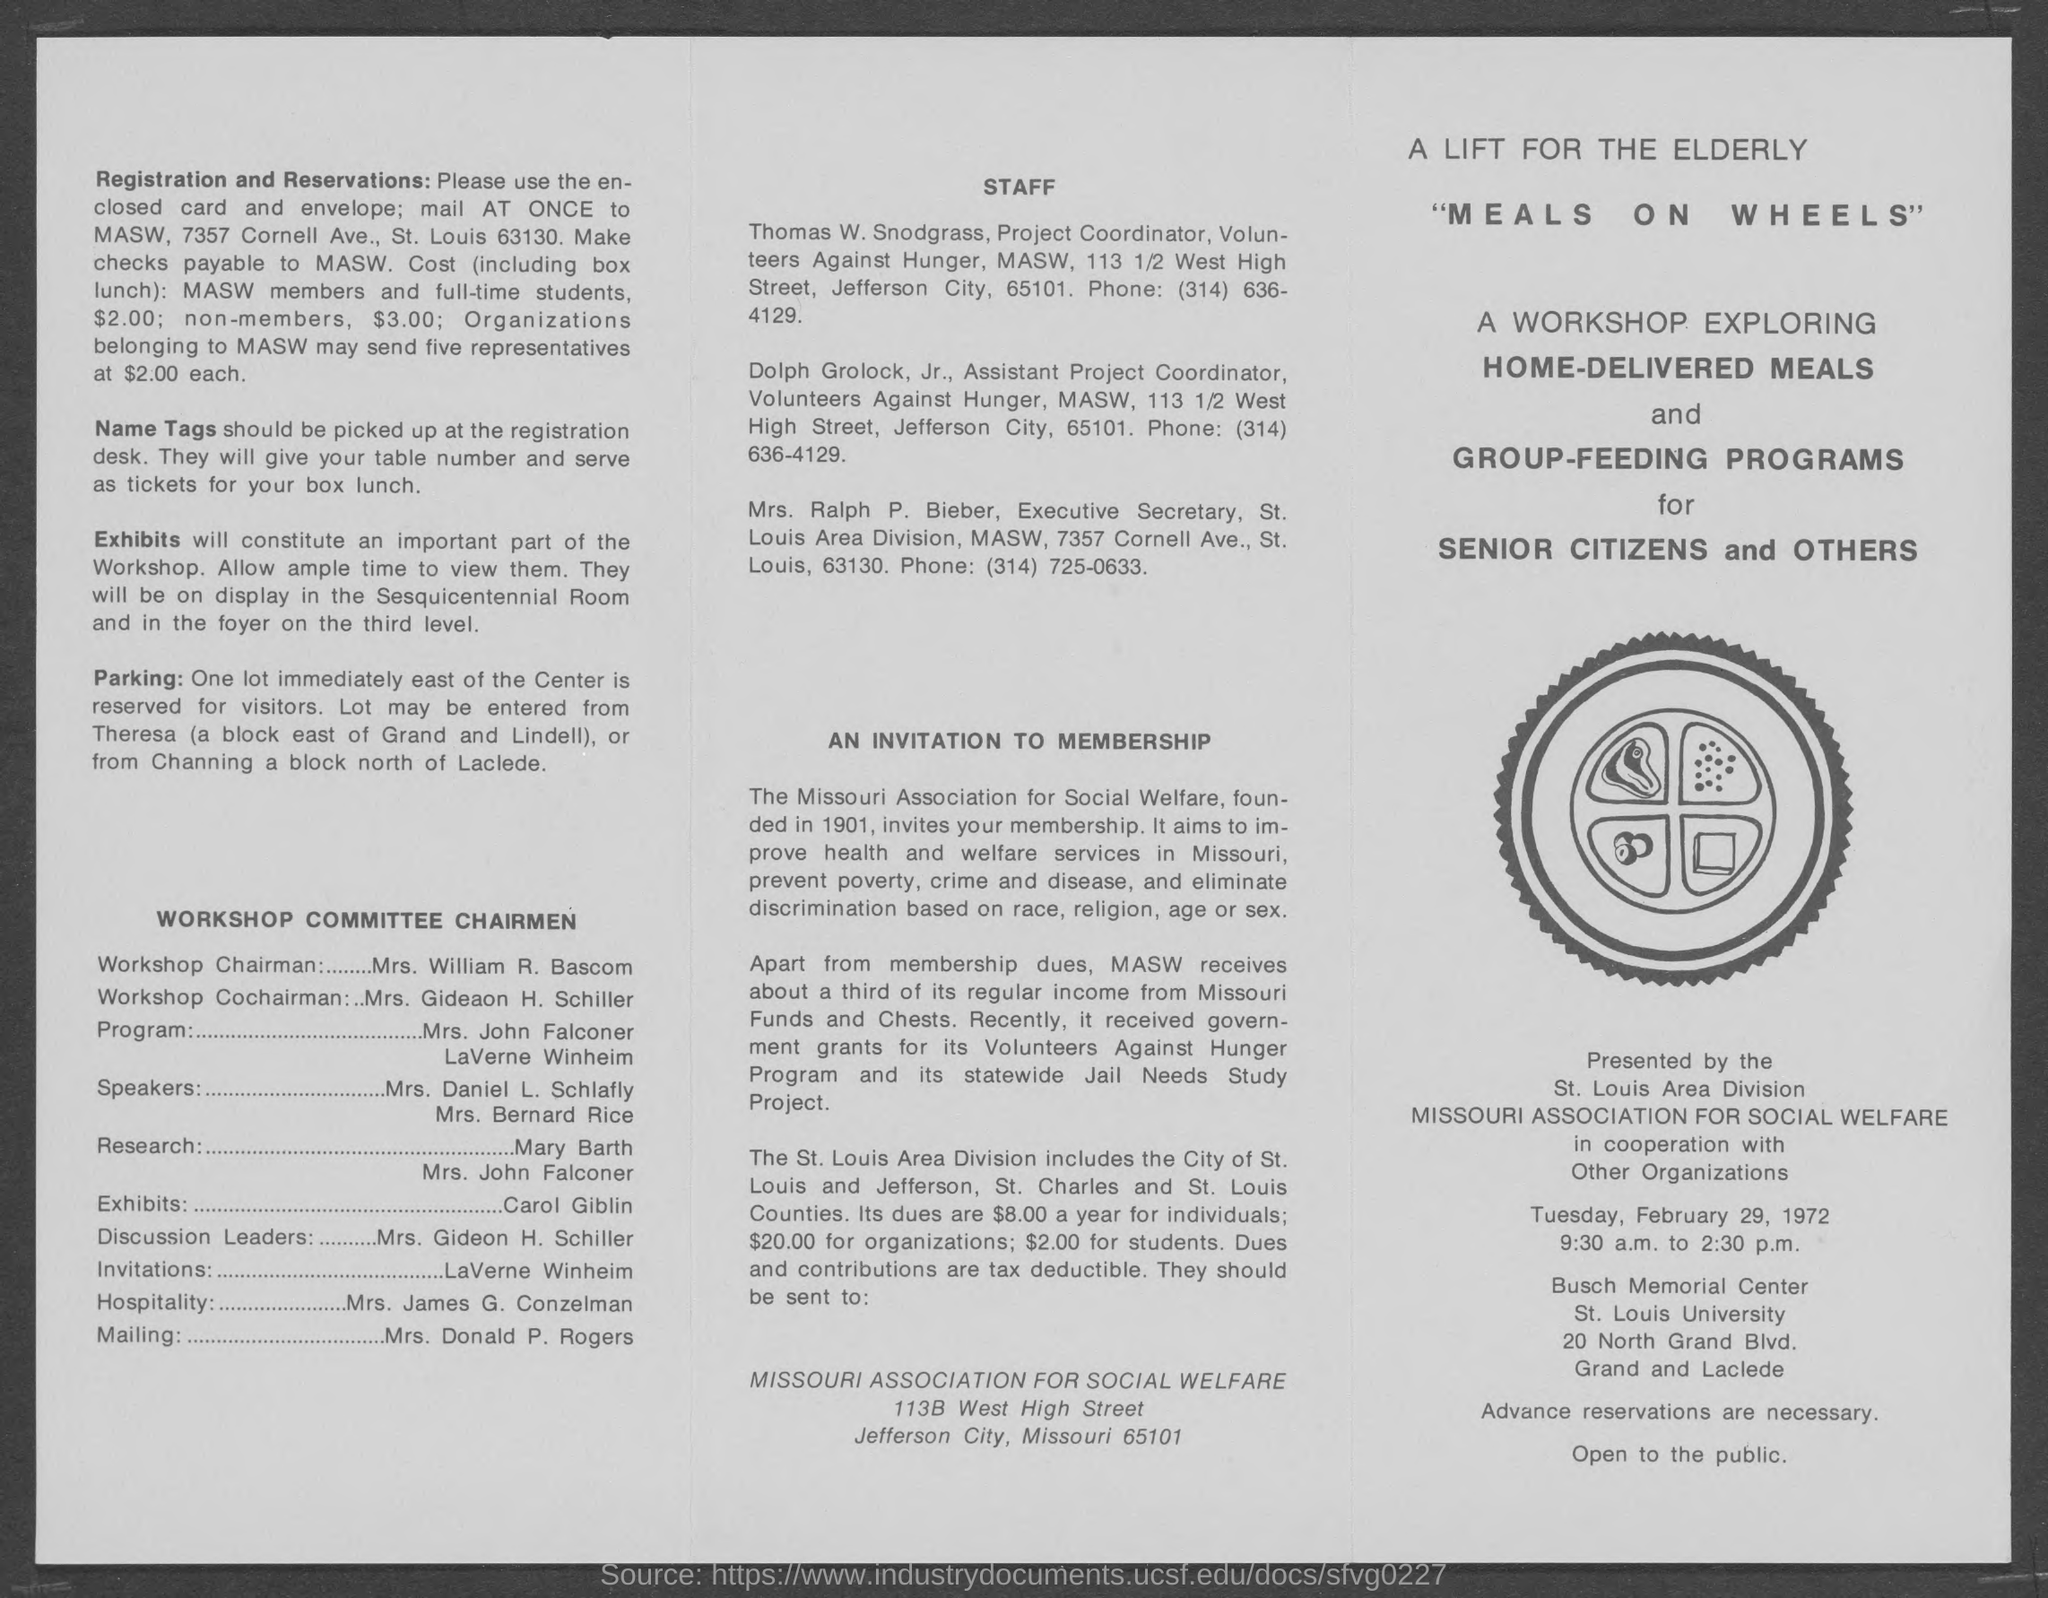What is the wrokshop's name?
Offer a terse response. "MEALS ON WHEELS". To whom should checks be payable?
Your response must be concise. MASW. Who is the workshop chairman?
Your answer should be compact. Mrs. William R. Bascom. Who is in charge of the Exhibits?
Your answer should be very brief. Carol Giblin. What is the duty of Mrs. Donald P. Rogers?
Make the answer very short. Mailing. At what time is the workshop?
Your answer should be compact. 9:30 a.m. to 2:30 p.m. 